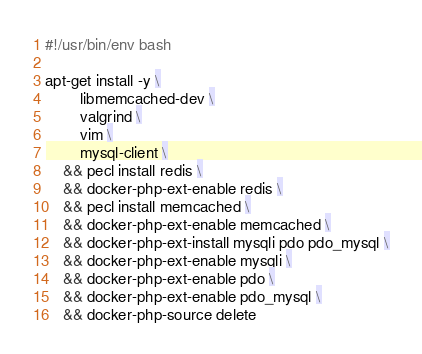<code> <loc_0><loc_0><loc_500><loc_500><_Bash_>#!/usr/bin/env bash

apt-get install -y \
        libmemcached-dev \
        valgrind \
        vim \
        mysql-client \
    && pecl install redis \
    && docker-php-ext-enable redis \
    && pecl install memcached \
    && docker-php-ext-enable memcached \
    && docker-php-ext-install mysqli pdo pdo_mysql \
    && docker-php-ext-enable mysqli \
    && docker-php-ext-enable pdo \
    && docker-php-ext-enable pdo_mysql \
    && docker-php-source delete
</code> 